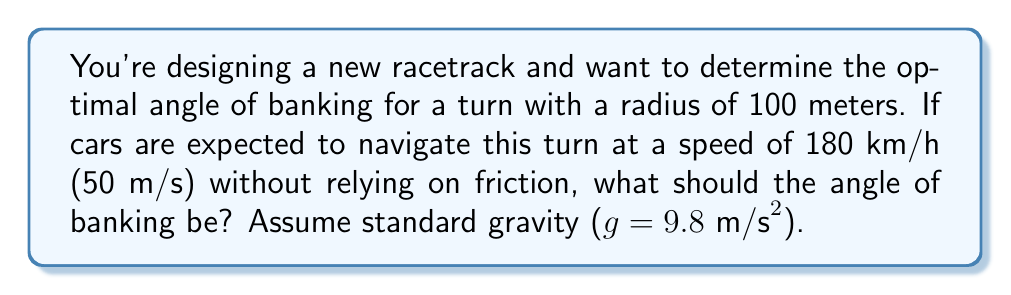Teach me how to tackle this problem. Let's approach this step-by-step:

1) For a banked turn without friction, the normal force provides the centripetal acceleration. We can use the formula:

   $$\tan \theta = \frac{v^2}{rg}$$

   Where:
   $\theta$ is the angle of banking
   $v$ is the velocity
   $r$ is the radius of the turn
   $g$ is the acceleration due to gravity

2) We're given:
   $v = 50 \text{ m/s}$
   $r = 100 \text{ m}$
   $g = 9.8 \text{ m/s}^2$

3) Let's substitute these values into our equation:

   $$\tan \theta = \frac{(50 \text{ m/s})^2}{(100 \text{ m})(9.8 \text{ m/s}^2)}$$

4) Simplify:

   $$\tan \theta = \frac{2500}{980} \approx 2.5510$$

5) To find $\theta$, we need to take the inverse tangent (arctan) of both sides:

   $$\theta = \arctan(2.5510)$$

6) Calculate:

   $$\theta \approx 68.63°$$

[asy]
import geometry;

size(200);
pair O=(0,0), A=(100,0), B=(100,100*tan(radians(68.63)));
draw(O--A--B--O);
draw(A--A+20*dir(90), arrow=Arrow);
label("$\theta$", A, NE);
label("Normal force", A+20*dir(90), E);
draw(arc(A,20,0,degrees(atan2(B.y,B.x))), arrow=Arrow);
[/asy]
Answer: $68.63°$ 